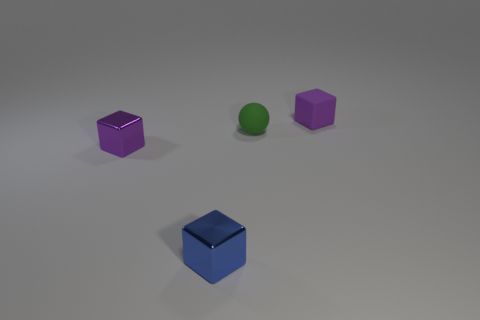Add 2 tiny rubber cubes. How many objects exist? 6 Subtract all balls. How many objects are left? 3 Subtract 0 yellow cubes. How many objects are left? 4 Subtract all large blue rubber objects. Subtract all matte objects. How many objects are left? 2 Add 3 small blue objects. How many small blue objects are left? 4 Add 1 blue things. How many blue things exist? 2 